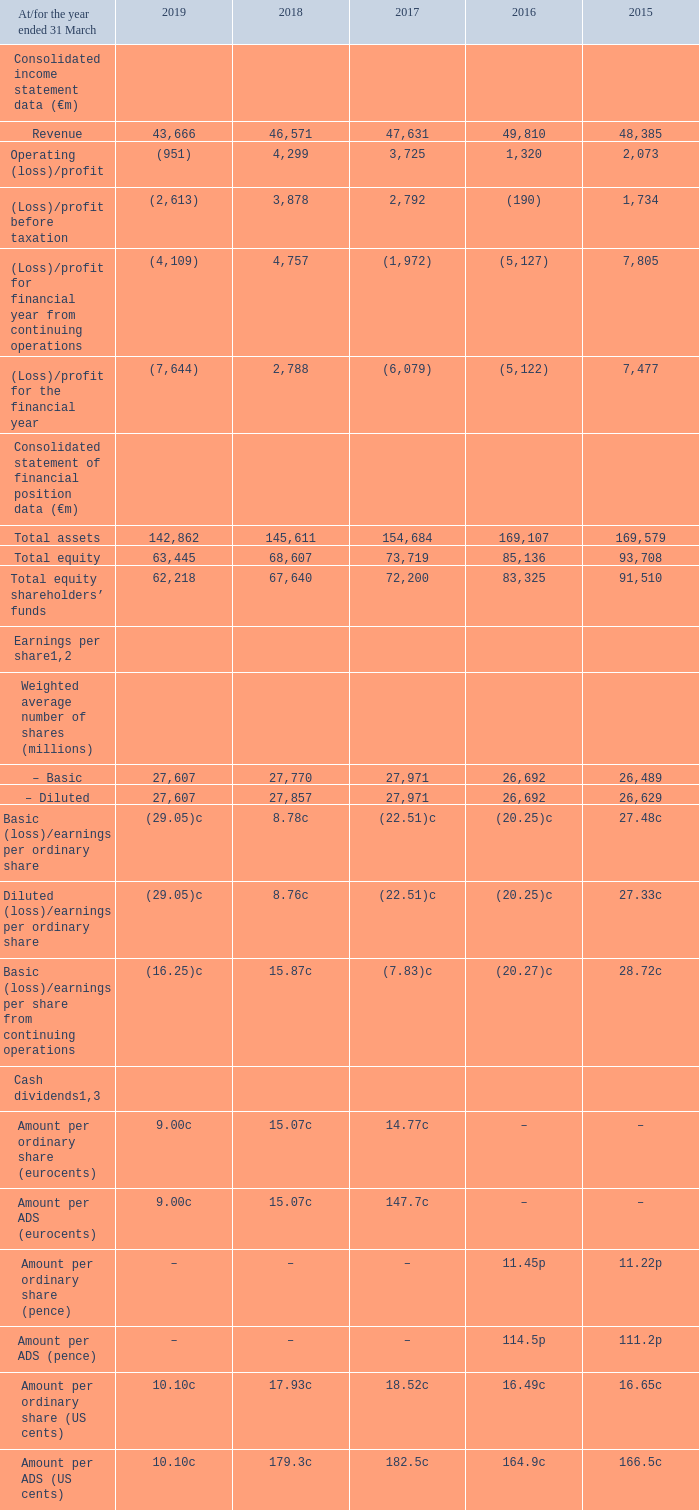Selected financial data
Unaudited information
The selected financial data shown below include the results of Vodafone India as discontinued operations in all years following the agreement to combine it with Idea Cellular.
Notes: 1 See note 8 to the consolidated financial statements, “Earnings per share”. Earnings and dividends per ADS is calculated by multiplying earnings per ordinary share by ten, the number of ordinary shares per ADS.
2 On 19 February 2014, we announced a “6 for 11” share consolidation effective 24 February 2014. This had the effect of reducing the number of shares in issue from 52,821,751,216 ordinary shares (including 4,351,833,492 ordinary shares held in Treasury) as at the close of business on 18 February 2014 to 28,811,864,298 new ordinary shares in issue immediately after the share consolidation on 24 February 2014.
3 The final dividend for the year ended 31 March 2019 was proposed by the Directors on 14 May 2019 and is payable on 2 August 2019 to holders of record as of 7 June 2019. The total dividends have been translated into US dollars at 31 March 2019 for purposes of the above disclosure but the dividends are payable in US dollars under the terms of the ADS depositary agreement.
Which financial years' information is shown in the table? 2015, 2016, 2017, 2018, 2019. What financial items does the consolidated income statement data comprise of? Revenue, operating (loss)/profit, (loss)/profit before taxation, (loss)/profit for financial year from continuing operations, (loss)/profit for the financial year. What financial items does the consolidated statement of financial position comprise of? Total assets, total equity, total equity shareholders’ funds. What is the average revenue for 2018 and 2019?
Answer scale should be: million. (43,666+46,571)/2
Answer: 45118.5. What is the average revenue for 2017 and 2018?
Answer scale should be: million. (46,571+47,631)/2
Answer: 47101. Between 2018 and 2019, which year has a higher amount of revenue? 46,571>43,666
Answer: 2018. 